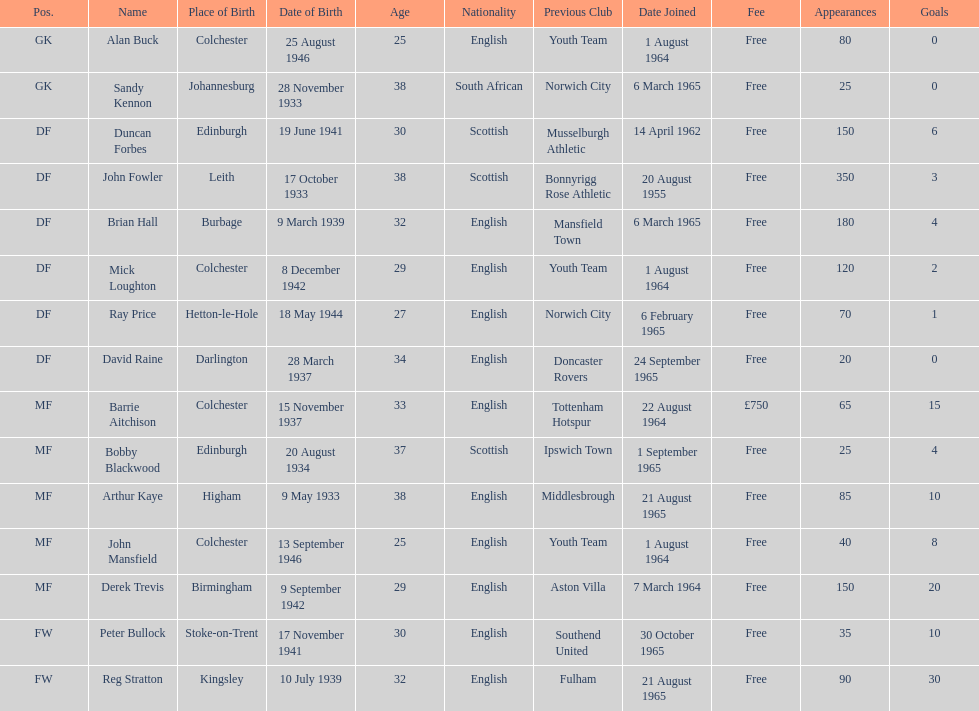Which team was ray price on before he started for this team? Norwich City. 